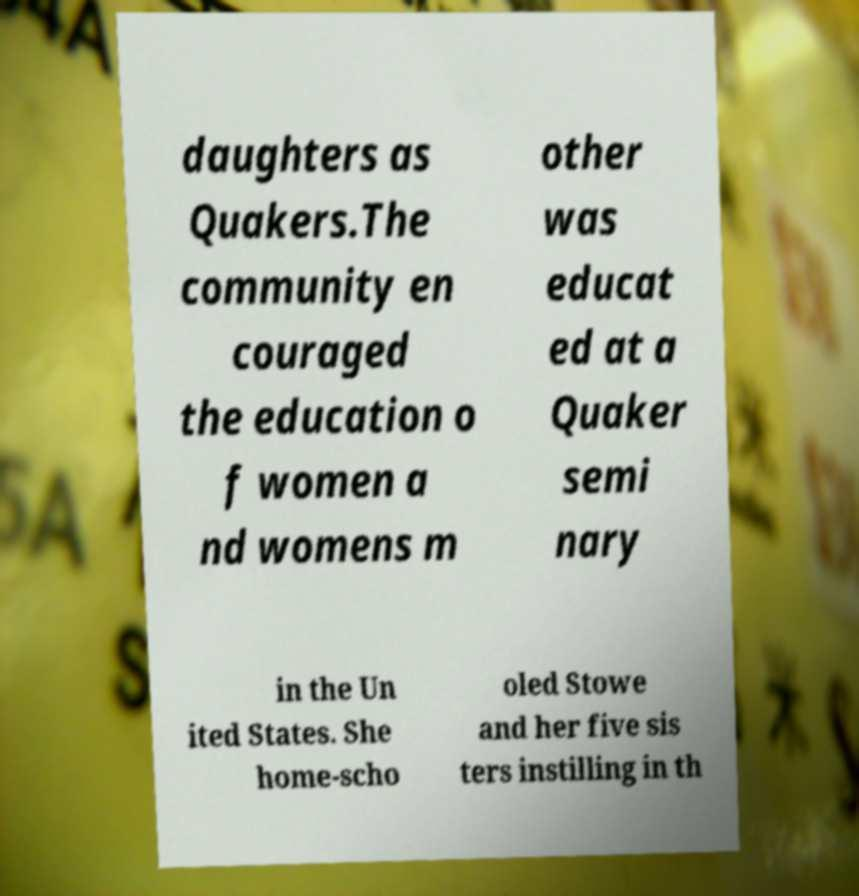There's text embedded in this image that I need extracted. Can you transcribe it verbatim? daughters as Quakers.The community en couraged the education o f women a nd womens m other was educat ed at a Quaker semi nary in the Un ited States. She home-scho oled Stowe and her five sis ters instilling in th 